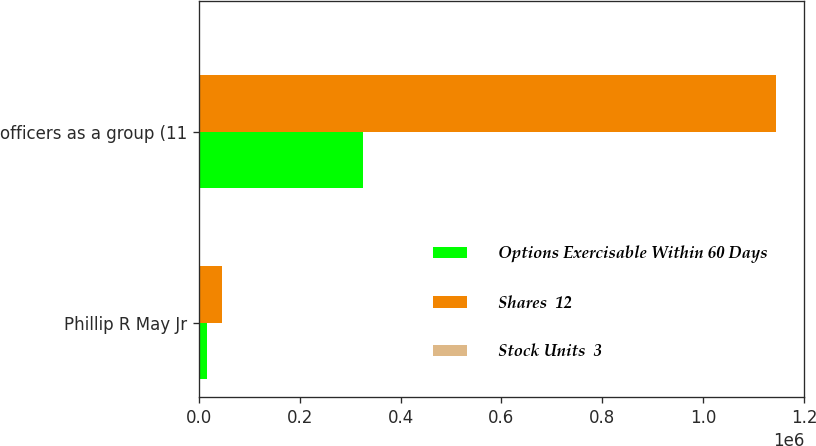Convert chart. <chart><loc_0><loc_0><loc_500><loc_500><stacked_bar_chart><ecel><fcel>Phillip R May Jr<fcel>officers as a group (11<nl><fcel>Options Exercisable Within 60 Days<fcel>16599<fcel>325961<nl><fcel>Shares  12<fcel>45233<fcel>1.14313e+06<nl><fcel>Stock Units  3<fcel>12<fcel>12<nl></chart> 